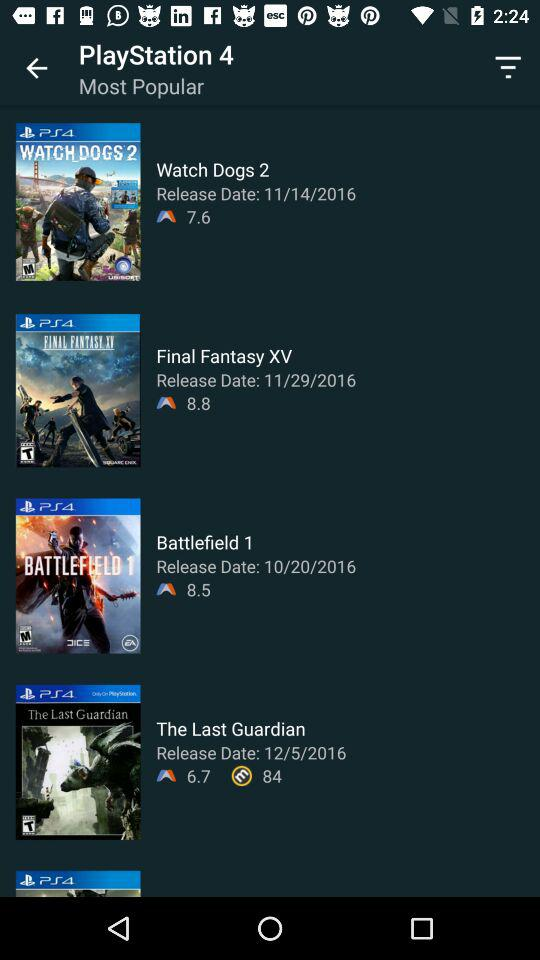How many games have a rating of 8.5 or higher?
Answer the question using a single word or phrase. 2 